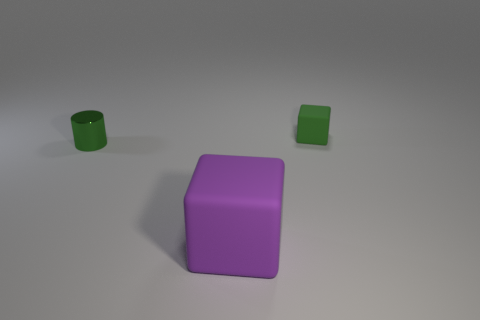There is a rubber block that is the same color as the cylinder; what size is it?
Keep it short and to the point. Small. Do the small shiny object and the green object right of the big thing have the same shape?
Give a very brief answer. No. There is a small thing that is on the right side of the big purple thing; how many green things are to the left of it?
Give a very brief answer. 1. What material is the other purple thing that is the same shape as the small matte thing?
Your answer should be very brief. Rubber. How many purple objects are big matte things or rubber objects?
Provide a short and direct response. 1. Are there any other things that are the same color as the large block?
Your answer should be compact. No. What is the color of the rubber thing that is left of the object behind the green shiny thing?
Make the answer very short. Purple. Is the number of cubes that are on the right side of the tiny green block less than the number of rubber objects that are to the left of the big matte object?
Keep it short and to the point. No. There is a small cylinder that is the same color as the tiny cube; what is it made of?
Your answer should be very brief. Metal. What number of things are cubes that are behind the small metal thing or metallic cylinders?
Your response must be concise. 2. 